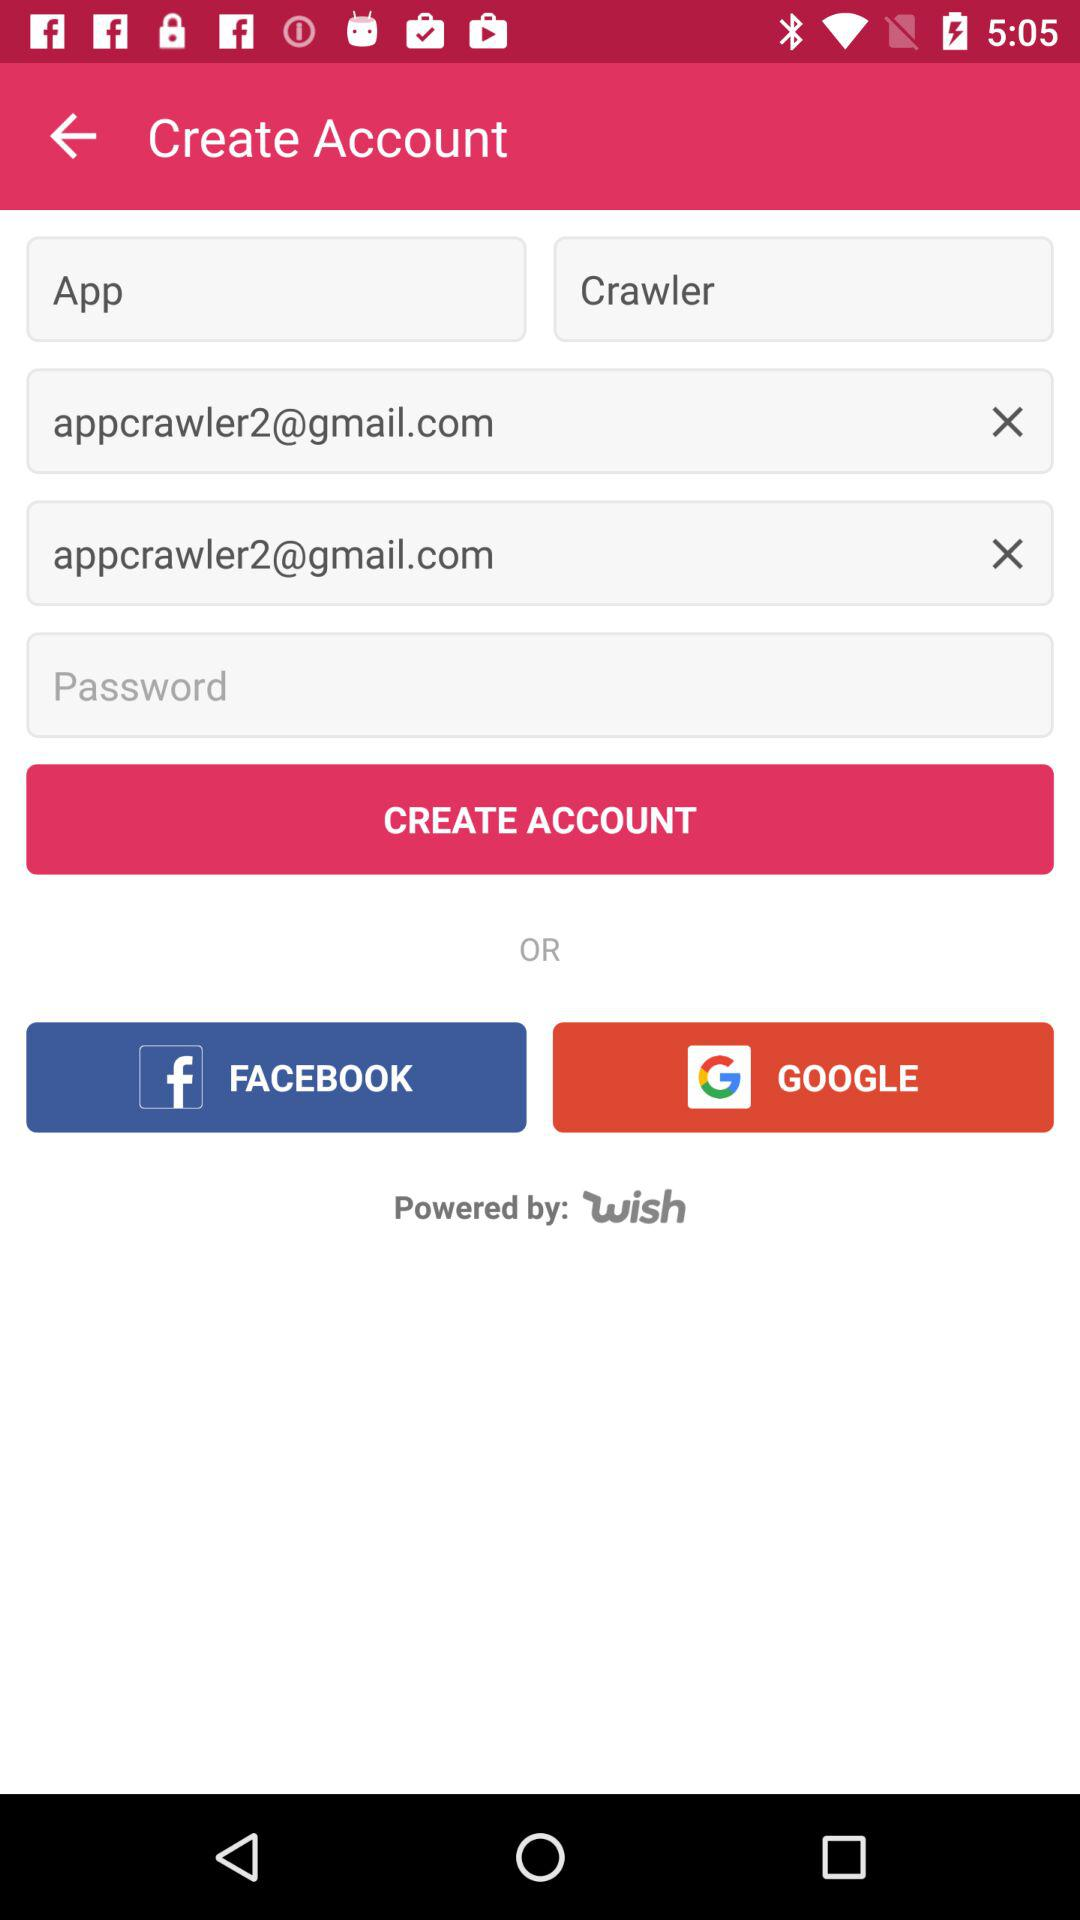What is the email address? The email address is appcrawler2@gmail.com. 